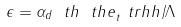Convert formula to latex. <formula><loc_0><loc_0><loc_500><loc_500>\epsilon = \alpha _ { d } \ t h \ t h e _ { t } ^ { \ } t r h h / \Lambda</formula> 